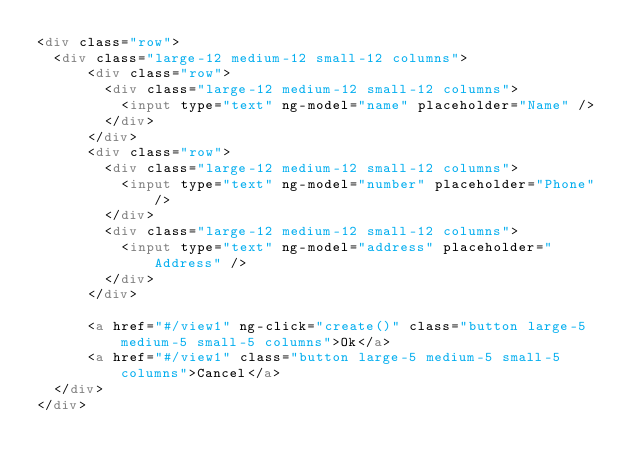<code> <loc_0><loc_0><loc_500><loc_500><_HTML_><div class="row">
	<div class="large-12 medium-12 small-12 columns">
			<div class="row">
				<div class="large-12 medium-12 small-12 columns">
    			<input type="text" ng-model="name" placeholder="Name" />
  			</div>
			</div>
			<div class="row">
				<div class="large-12 medium-12 small-12 columns">
					<input type="text" ng-model="number" placeholder="Phone" />
				</div>
				<div class="large-12 medium-12 small-12 columns">
					<input type="text" ng-model="address" placeholder="Address" />
				</div>
			</div>
			
			<a href="#/view1" ng-click="create()" class="button large-5 medium-5 small-5 columns">Ok</a>
			<a href="#/view1" class="button large-5 medium-5 small-5 columns">Cancel</a>
	</div>
</div>
</code> 